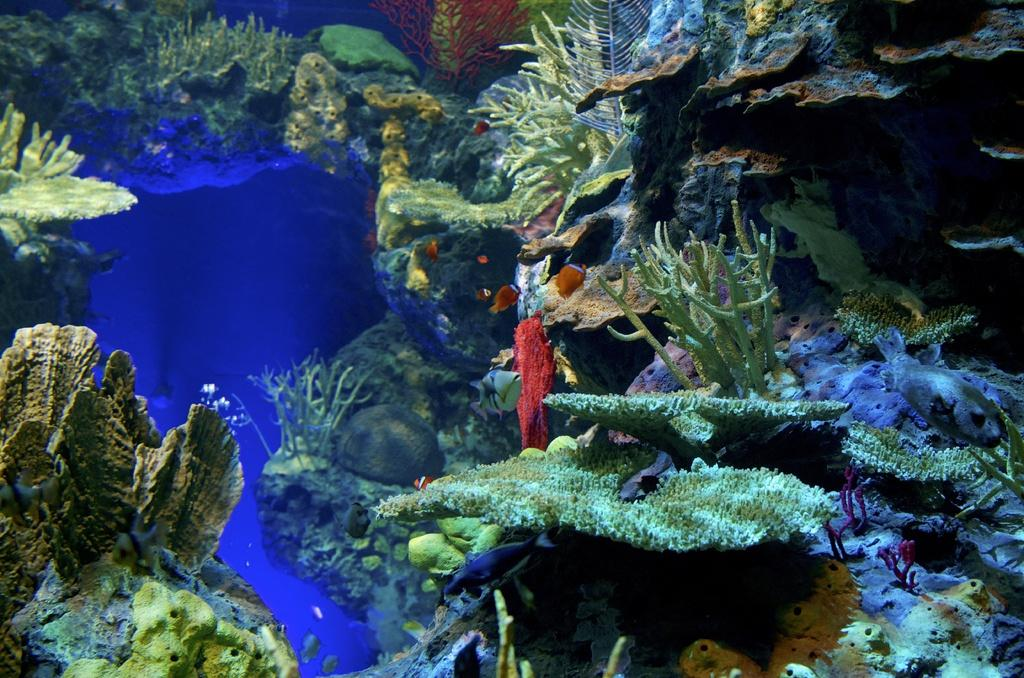What type of environment is shown in the image? The image depicts an underwater environment. What can be found in this underwater environment? There are corals and fishes in the image. What book is the fish reading in the image? There are no books or reading depicted in the image, as it is an underwater environment with corals and fishes. 